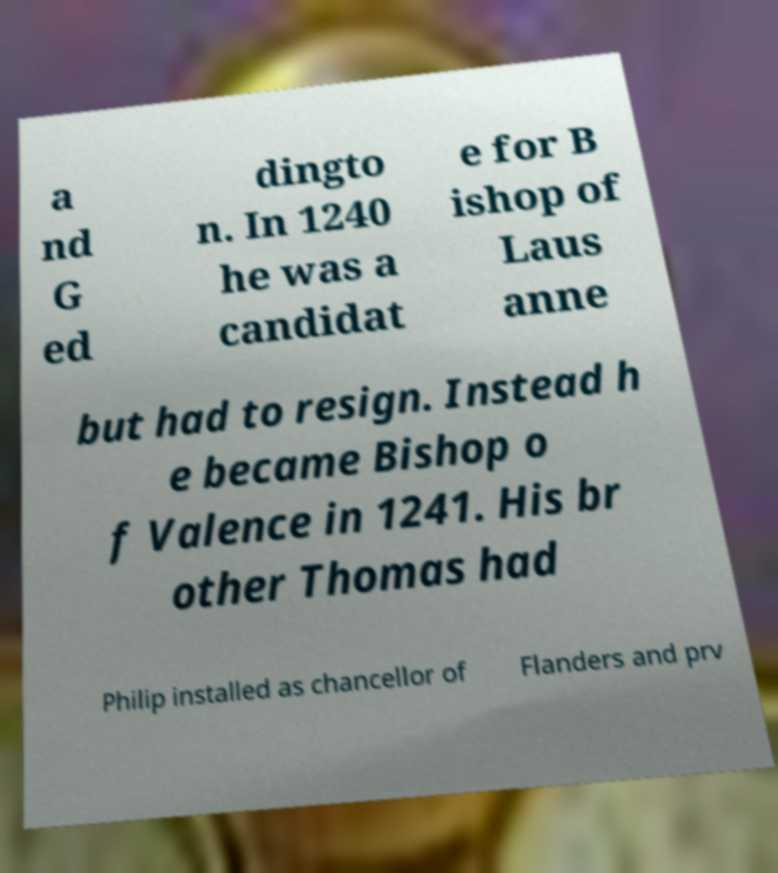Please read and relay the text visible in this image. What does it say? a nd G ed dingto n. In 1240 he was a candidat e for B ishop of Laus anne but had to resign. Instead h e became Bishop o f Valence in 1241. His br other Thomas had Philip installed as chancellor of Flanders and prv 